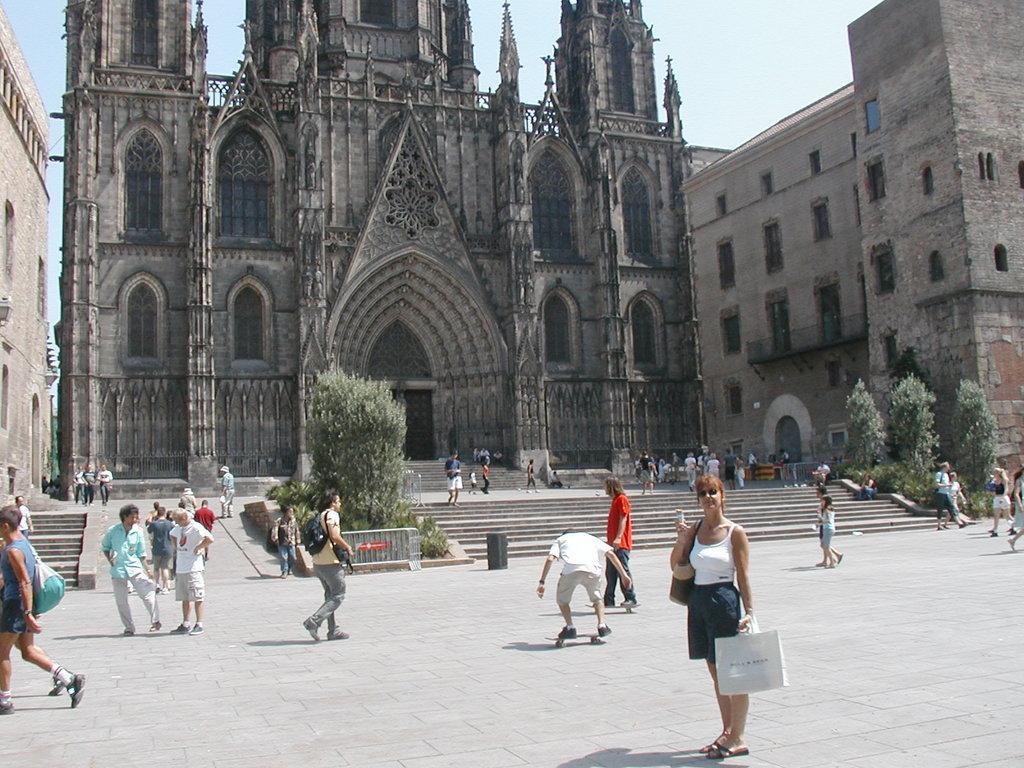Can you describe this image briefly? In this image, we can see a group of people, few people are walking and few people are standing on the floor. In the middle, we can see a man riding on the skateboard. In the middle of the image, we can also see a woman standing and holding a carry bag. In the background, we can see some trees, building, glass window. At the top, we can see a sky, at the bottom, we can see a staircase and a land. 